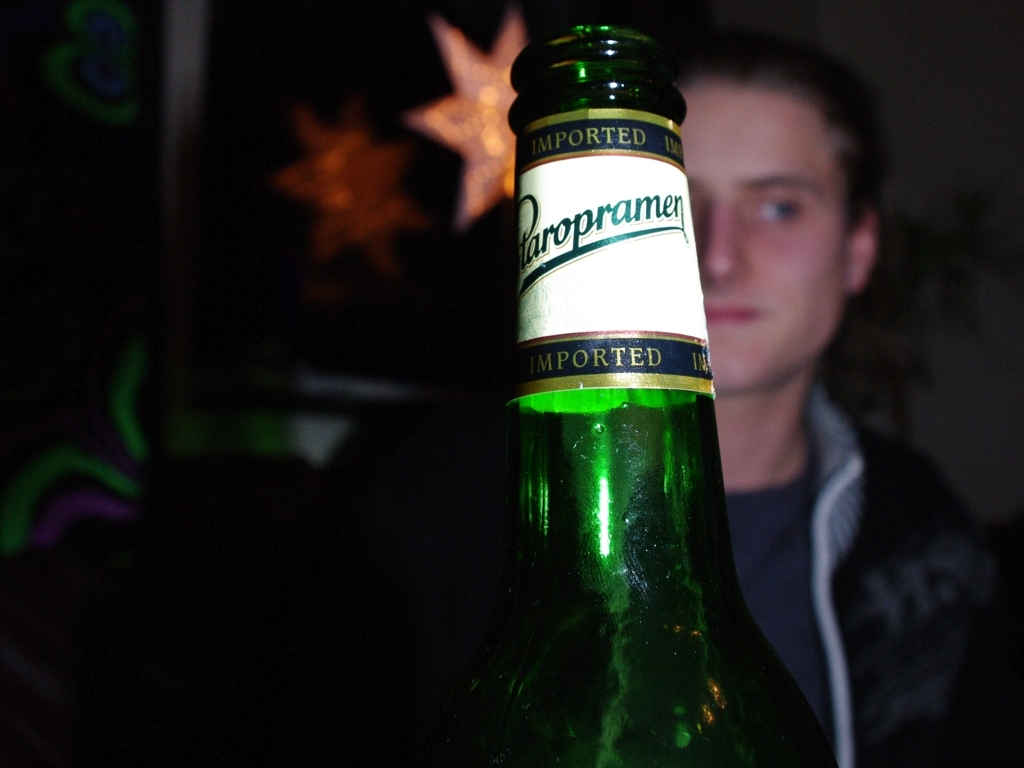Can you tell me what the main subject of the image is? The main subject appears to be the green bottle in the foreground, given that it is in sharp focus and well-lit compared to the other elements in the frame. 